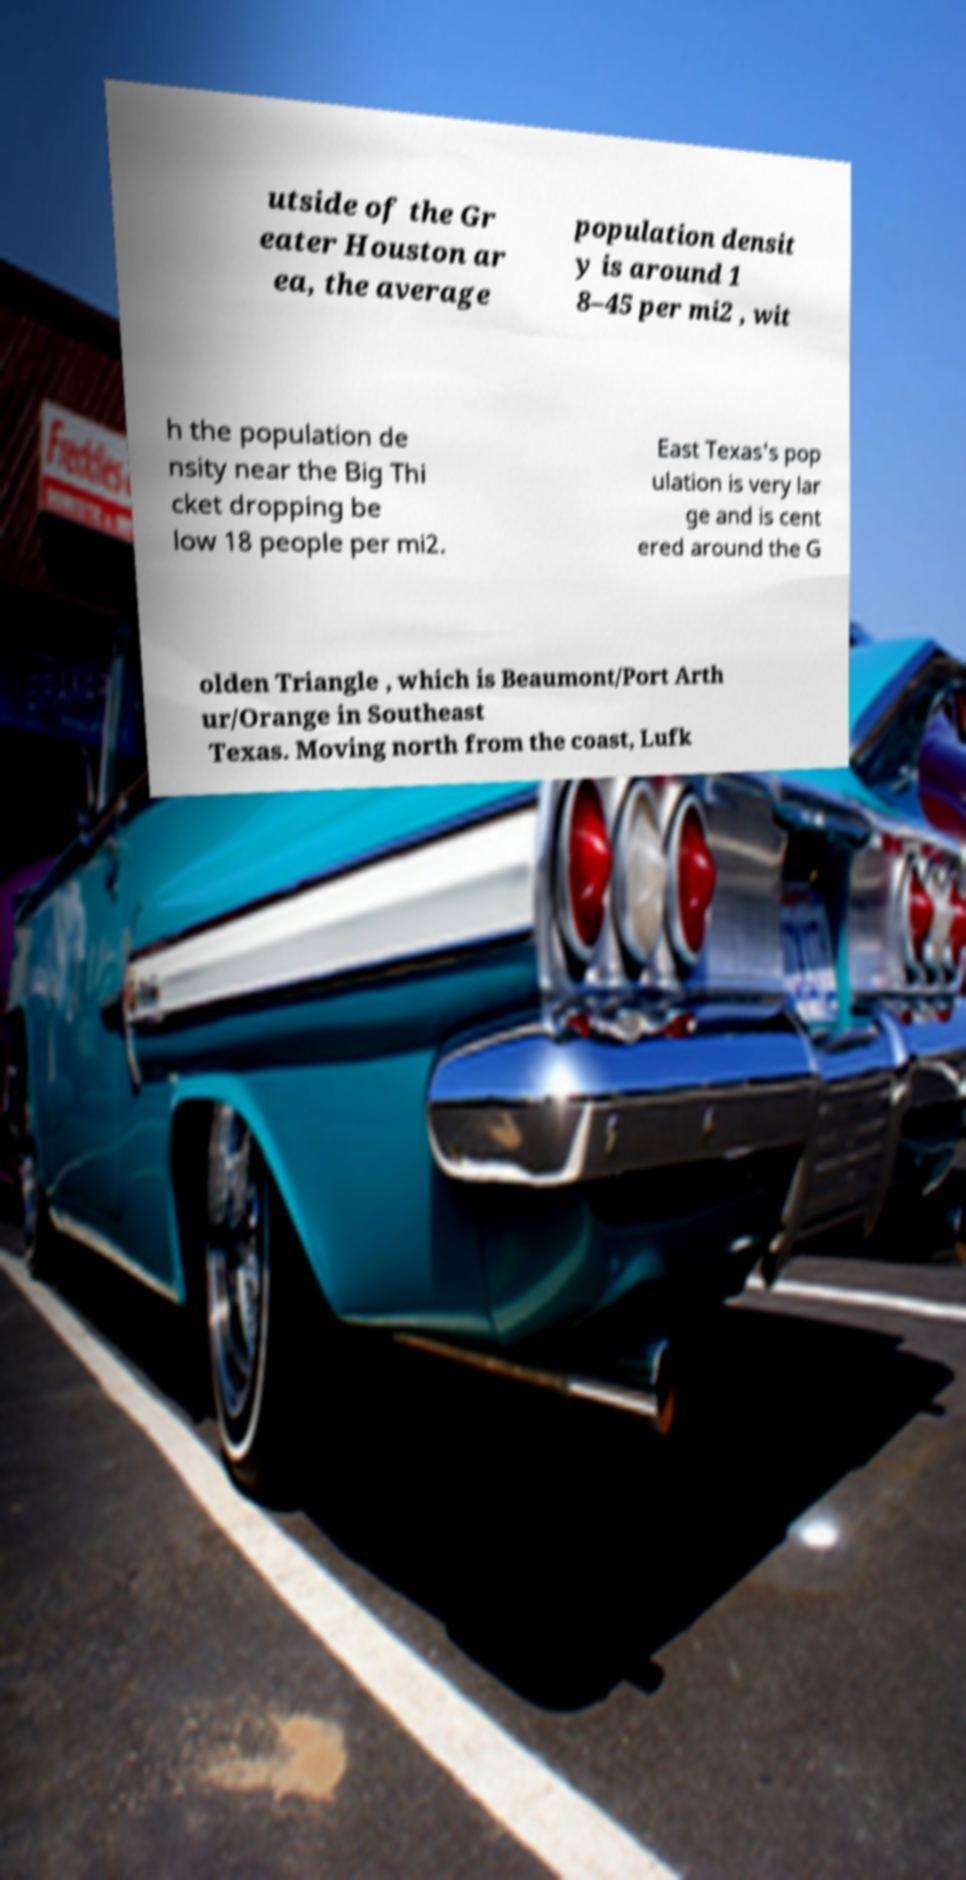Please read and relay the text visible in this image. What does it say? utside of the Gr eater Houston ar ea, the average population densit y is around 1 8–45 per mi2 , wit h the population de nsity near the Big Thi cket dropping be low 18 people per mi2. East Texas's pop ulation is very lar ge and is cent ered around the G olden Triangle , which is Beaumont/Port Arth ur/Orange in Southeast Texas. Moving north from the coast, Lufk 